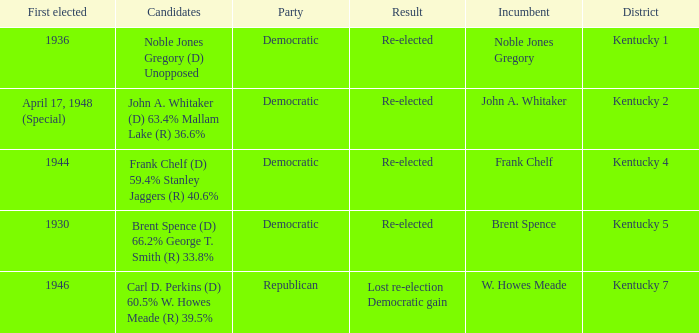Who were the candidates in the Kentucky 4 voting district? Frank Chelf (D) 59.4% Stanley Jaggers (R) 40.6%. 